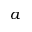Convert formula to latex. <formula><loc_0><loc_0><loc_500><loc_500>a</formula> 